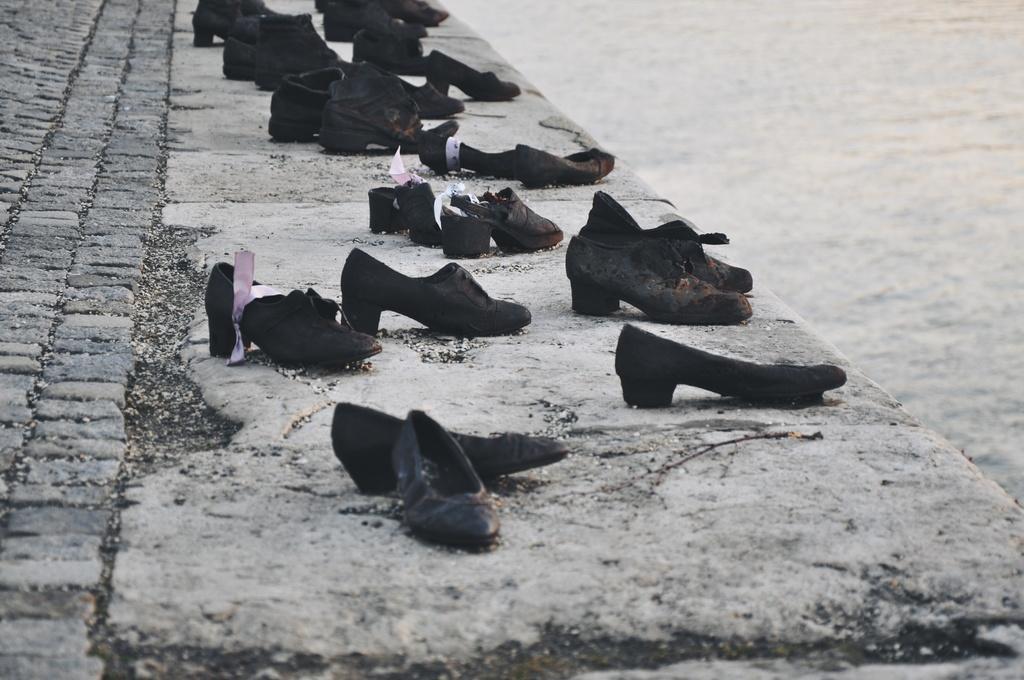Could you give a brief overview of what you see in this image? In the center of the image we can see shoes placed on the ground. On the right side of the image we can see water. 